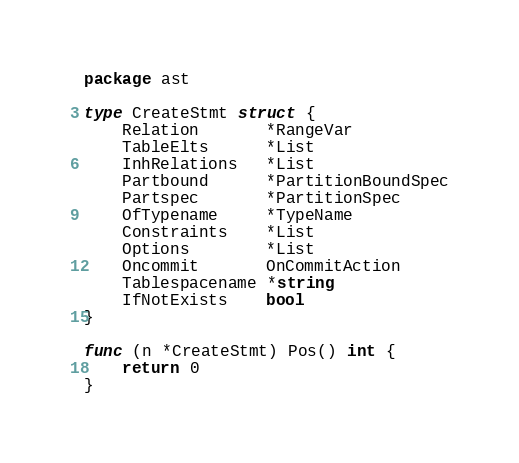<code> <loc_0><loc_0><loc_500><loc_500><_Go_>package ast

type CreateStmt struct {
	Relation       *RangeVar
	TableElts      *List
	InhRelations   *List
	Partbound      *PartitionBoundSpec
	Partspec       *PartitionSpec
	OfTypename     *TypeName
	Constraints    *List
	Options        *List
	Oncommit       OnCommitAction
	Tablespacename *string
	IfNotExists    bool
}

func (n *CreateStmt) Pos() int {
	return 0
}
</code> 